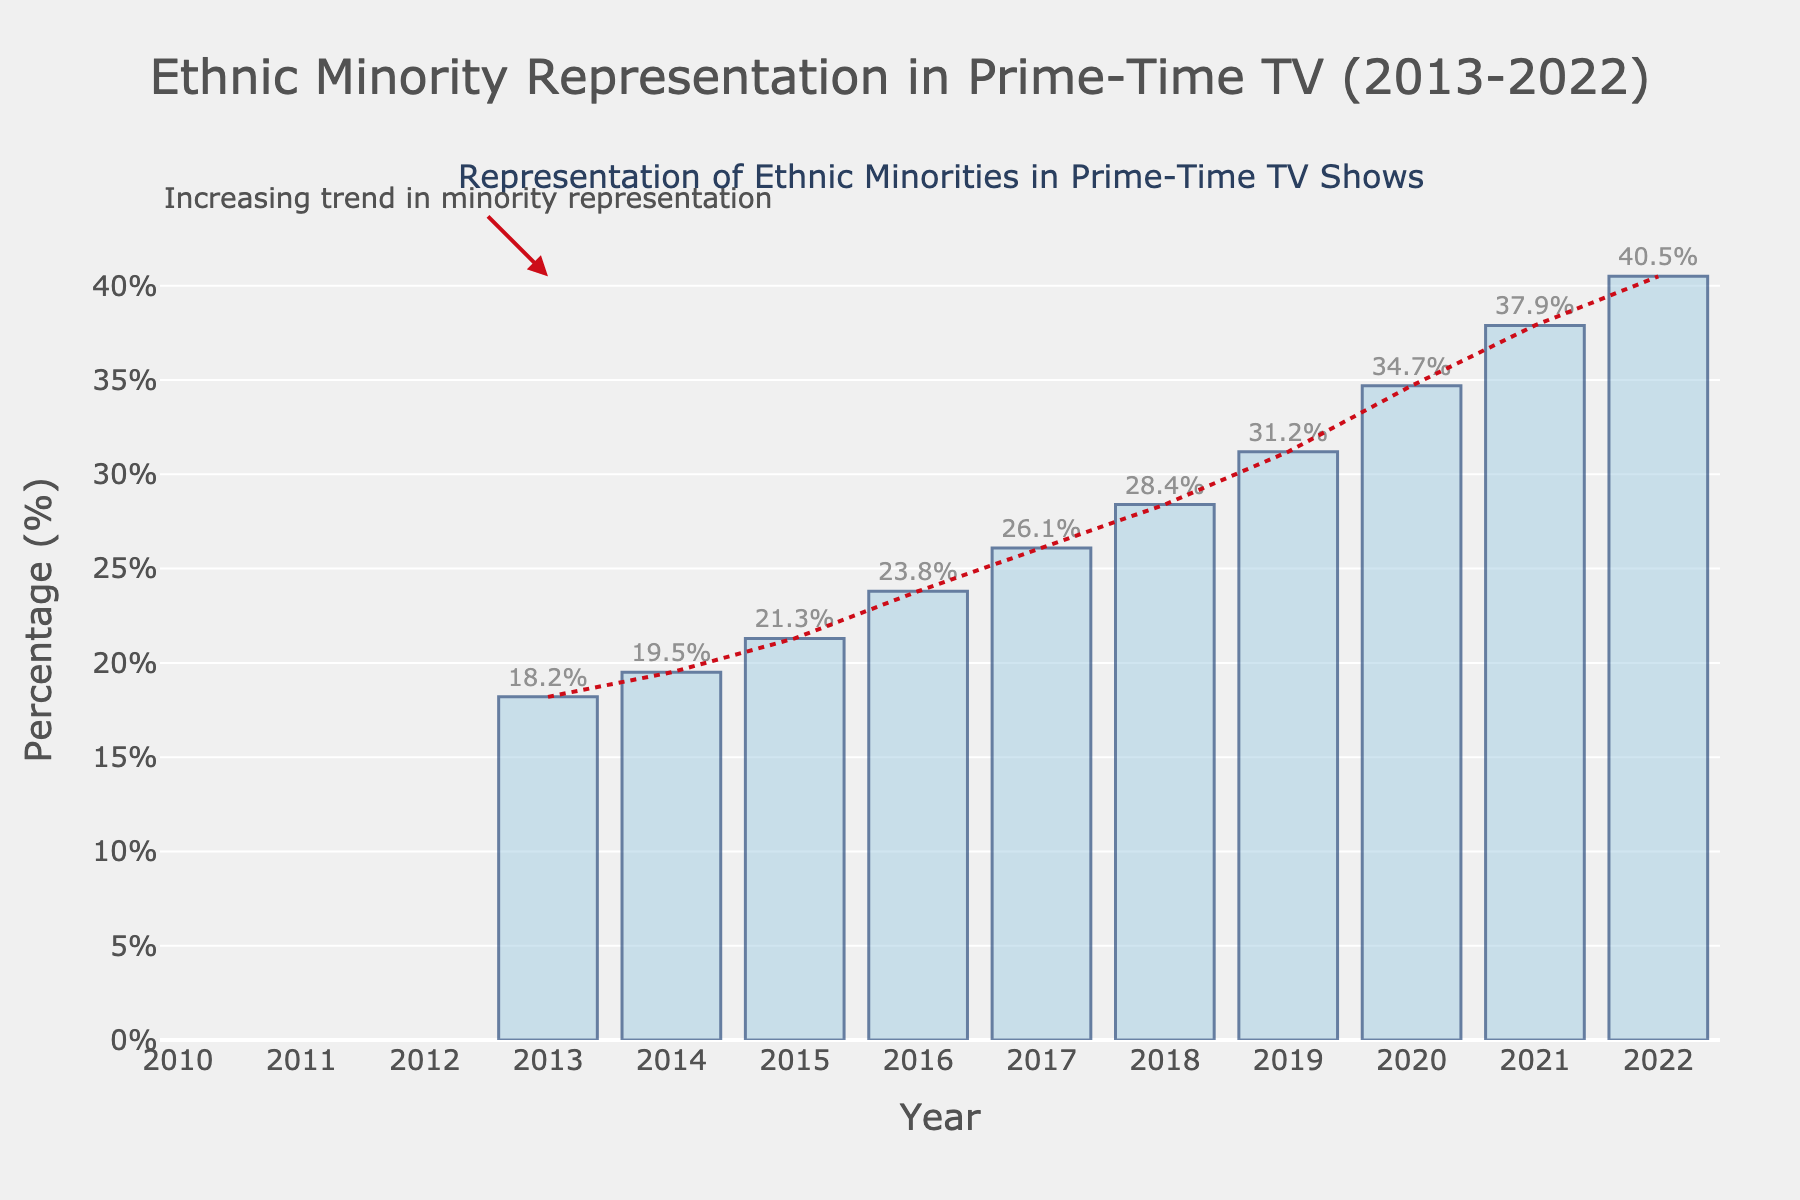What was the increase in representation from 2013 to 2022? The percentage in 2013 was 18.2%, and in 2022 it was 40.5%. To find the increase, we subtract the earlier percentage from the later percentage: 40.5% - 18.2% = 22.3%.
Answer: 22.3% Between which consecutive years was the largest increase in representation observed? By comparing the increases year by year, the largest increase is found between 2019 (31.2%) and 2020 (34.7%). The increase is 34.7% - 31.2% = 3.5%.
Answer: 2019 to 2020 What is the average representation over the decade shown? Sum all the percentages from 2013 to 2022: 18.2 + 19.5 + 21.3 + 23.8 + 26.1 + 28.4 + 31.2 + 34.7 + 37.9 + 40.5 = 281.6. Then divide by the number of years (10): 281.6 / 10 = 28.16%.
Answer: 28.16% In which year did the representation cross 30%? By looking at the bars, the year where the percentage first crosses 30% is 2019.
Answer: 2019 How does the height of the bar in 2016 compare to the height of the bar in 2015? The height of the bar in 2016 represents 23.8%, and the height in 2015 represents 21.3%. Therefore, 23.8% is greater than 21.3%.
Answer: Greater Which year has the highest percentage of representation? By examining the highest bar, which corresponds to 2022, we see the percentage is 40.5%.
Answer: 2022 What is the difference in percentage representation between the years 2017 and 2018? Subtract the percentage in 2017 (26.1%) from that in 2018 (28.4%): 28.4% - 26.1% = 2.3%.
Answer: 2.3% What trend is observed over the period 2013 to 2022? The figure includes a trend line that shows an increasing trend in the representation of ethnic minorities in prime-time TV shows. This is also visually supported by consistently rising bar heights.
Answer: Increasing When does the representation reach an approximately mid-way point (around 30%) for the first time during the period? By examining the bar heights, the year 2019 is when representation first hits 31.2%, close to mid-way point (30%).
Answer: 2019 